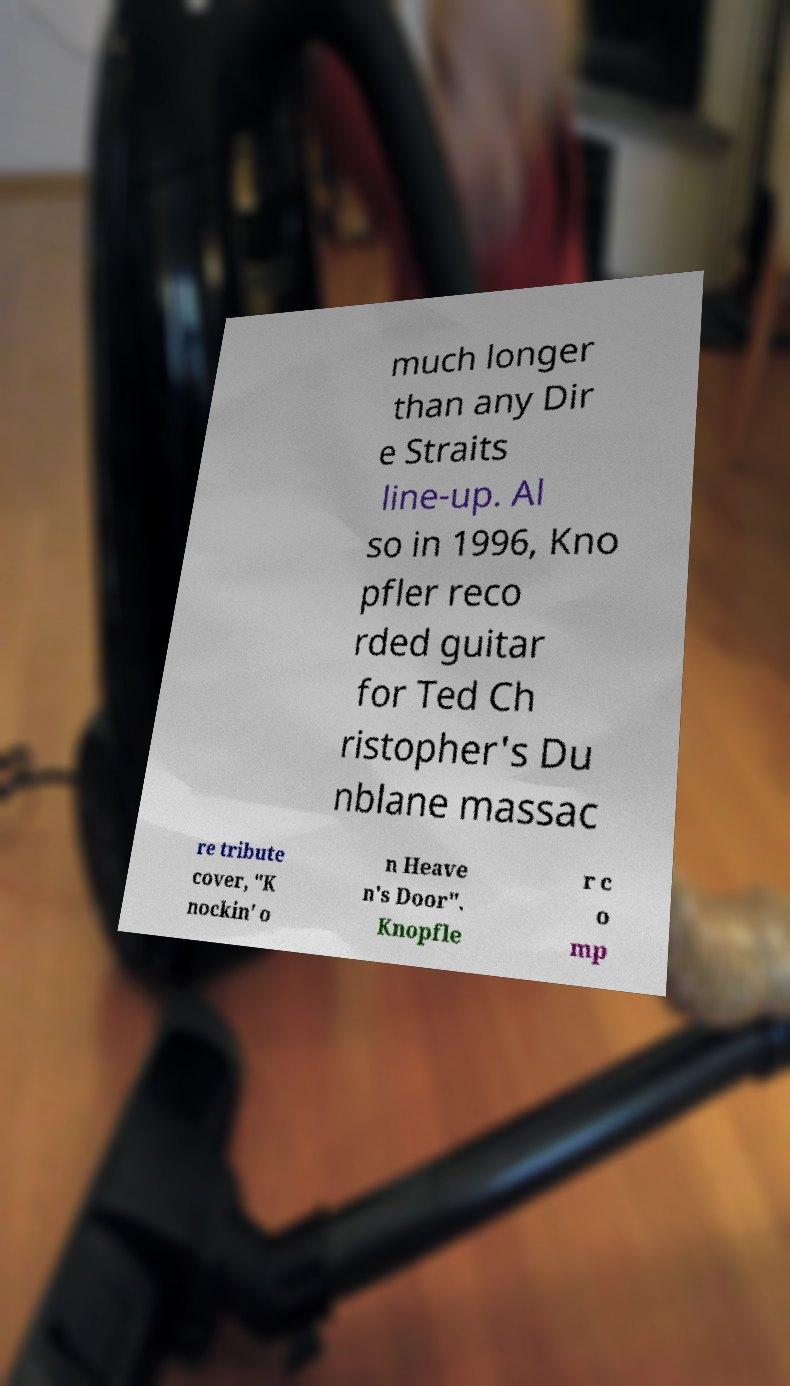Please read and relay the text visible in this image. What does it say? much longer than any Dir e Straits line-up. Al so in 1996, Kno pfler reco rded guitar for Ted Ch ristopher's Du nblane massac re tribute cover, "K nockin' o n Heave n's Door". Knopfle r c o mp 